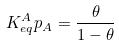<formula> <loc_0><loc_0><loc_500><loc_500>K _ { e q } ^ { A } p _ { A } = \frac { \theta } { 1 - \theta }</formula> 